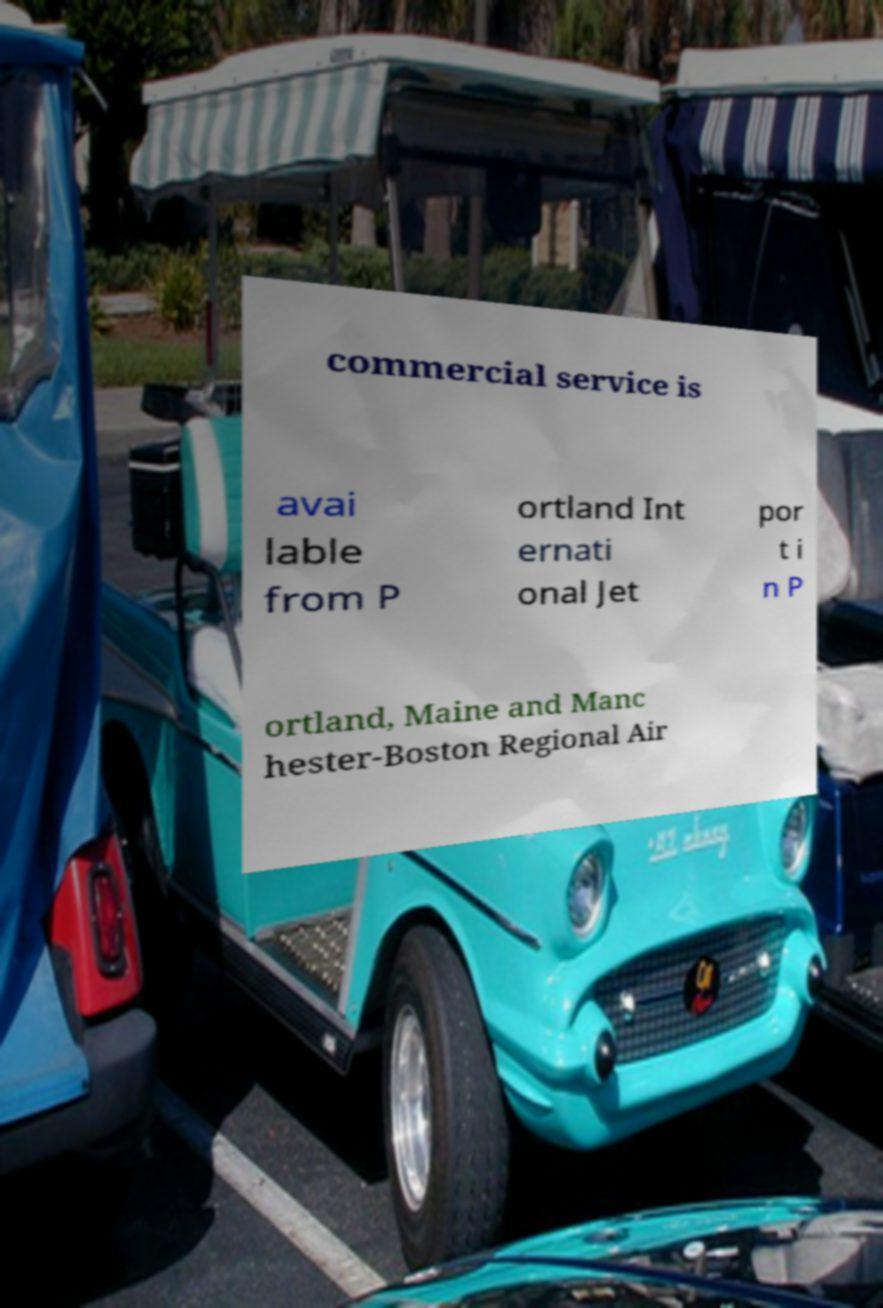I need the written content from this picture converted into text. Can you do that? commercial service is avai lable from P ortland Int ernati onal Jet por t i n P ortland, Maine and Manc hester-Boston Regional Air 